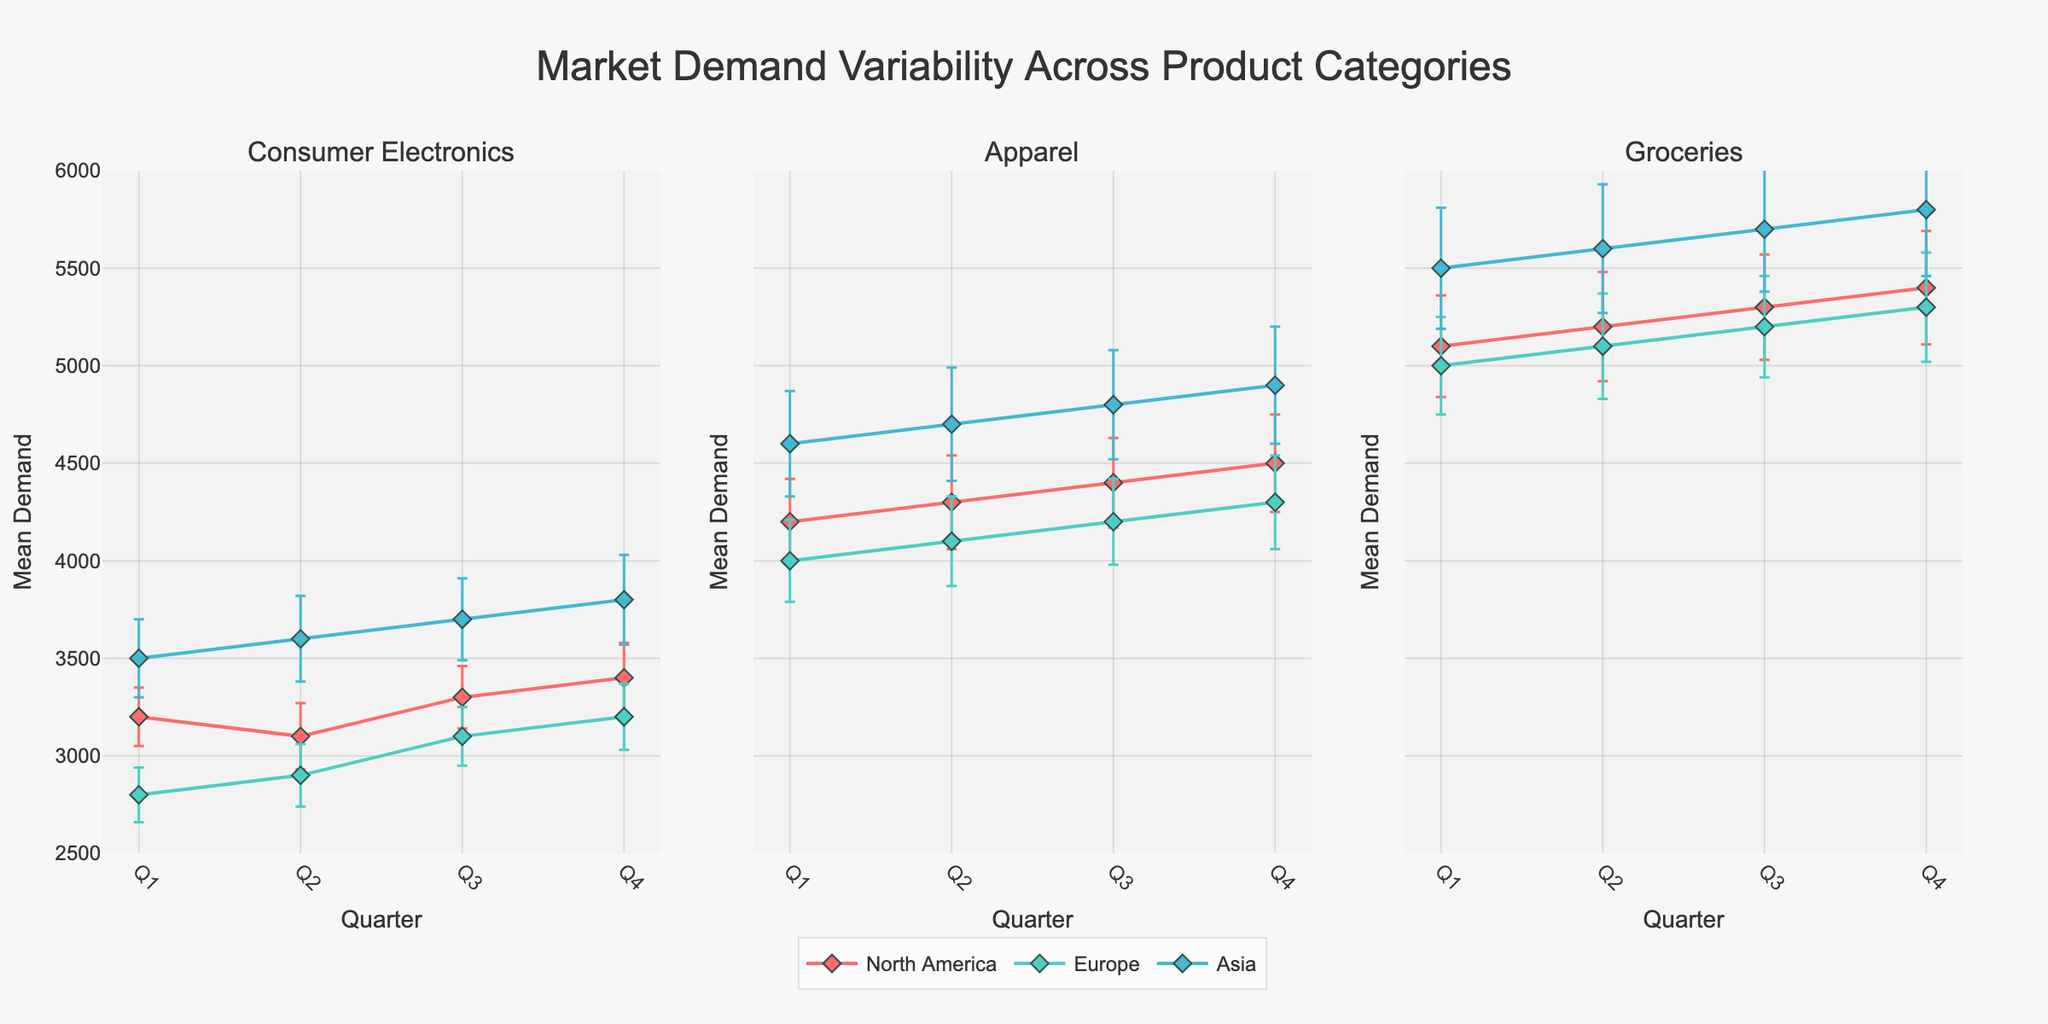what is the title of the figure? The title is displayed prominently at the top and is typically larger and in bold to highlight the main topic of the visualization. The title usually summarizes what the figure is about.
Answer: Market Demand Variability Across Product Categories Which product category has the highest mean demand in Q4 in Asia? To answer this, observe the figures which show the demand across different product categories. Look for the Q4 data points for Asia in each subplot and identify the highest mean demand.
Answer: Groceries What is the color used to represent the North American region? The color legend at the bottom of the figure helps in mapping colors to regions. Identify the color label assigned to 'North America'. It is generally consistent across all subplots.
Answer: Red which region shows the highest variability in Groceries demand? Variability is represented by the error bars; larger error bars indicate higher standard deviation. Check the error bars for the Groceries category in each region.
Answer: Asia How does Q1 demand for Consumer Electronics in Europe compare to Q2? To compare, find the Q1 and Q2 data points for Consumer Electronics in Europe in the respective subplot. Observe the mean demand values and note which one is higher.
Answer: Q2 is higher Which region has the lowest demand for Apparel in Q3? Examine the Q3 data points for the Apparel category across all regions. The lowest point indicates the lowest demand.
Answer: Europe What is the range of mean demands for Consumer Electronics across all quarters in North America? Identify the highest and lowest mean demand values for North America in the Consumer Electronics subplot. The range is the difference between these two values.
Answer: 3100 to 3400 What is the difference in Q4 mean demand for Groceries between Asia and Europe? Locate Q4 mean demand values for Groceries in Asia and Europe. Subtract the European value from the Asian value to get the difference.
Answer: 500 In which quarter does Apparel in North America have the lowest demand? Examine the mean demand values for each quarter in the Apparel subplot for North America. Identify the quarter with the smallest value.
Answer: Q1 Are the mean demands for Consumer Electronics higher in North America or Asia across all quarters? Compare the mean demand values for Consumer Electronics in North America and Asia for each quarter. Determine which region consistently has higher values.
Answer: Asia 